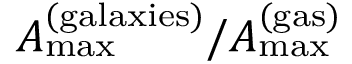Convert formula to latex. <formula><loc_0><loc_0><loc_500><loc_500>A _ { \max } ^ { ( g a l a x i e s ) } / A _ { \max } ^ { ( g a s ) }</formula> 